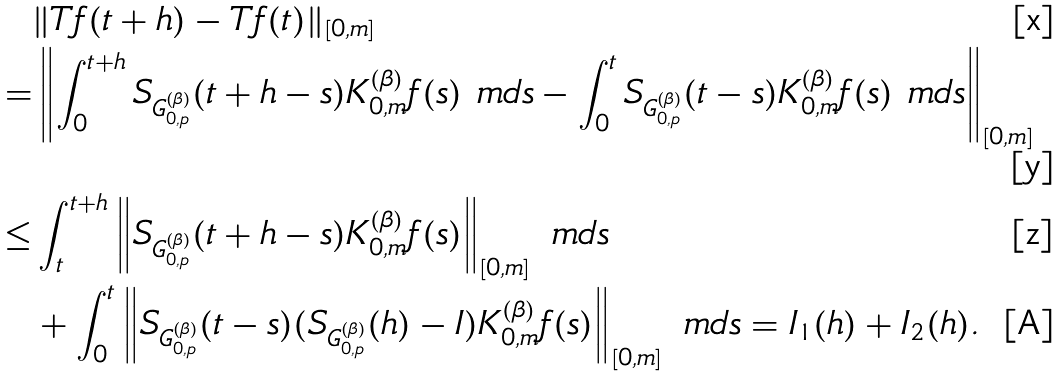<formula> <loc_0><loc_0><loc_500><loc_500>& \| T f ( t + h ) - T f ( t ) \| _ { [ 0 , m ] } \\ = & \left \| \int _ { 0 } ^ { t + h } S _ { G _ { 0 , p } ^ { ( \beta ) } } ( t + h - s ) K _ { 0 , m } ^ { ( \beta ) } f ( s ) \ m d s - \int _ { 0 } ^ { t } S _ { G _ { 0 , p } ^ { ( \beta ) } } ( t - s ) K _ { 0 , m } ^ { ( \beta ) } f ( s ) \ m d s \right \| _ { [ 0 , m ] } \\ \leq & \int _ { t } ^ { t + h } \left \| S _ { G _ { 0 , p } ^ { ( \beta ) } } ( t + h - s ) K _ { 0 , m } ^ { ( \beta ) } f ( s ) \right \| _ { [ 0 , m ] } \ m d s \\ & + \int _ { 0 } ^ { t } \left \| S _ { G _ { 0 , p } ^ { ( \beta ) } } ( t - s ) ( S _ { G _ { 0 , p } ^ { ( \beta ) } } ( h ) - I ) K _ { 0 , m } ^ { ( \beta ) } f ( s ) \right \| _ { [ 0 , m ] } \ m d s = I _ { 1 } ( h ) + I _ { 2 } ( h ) .</formula> 